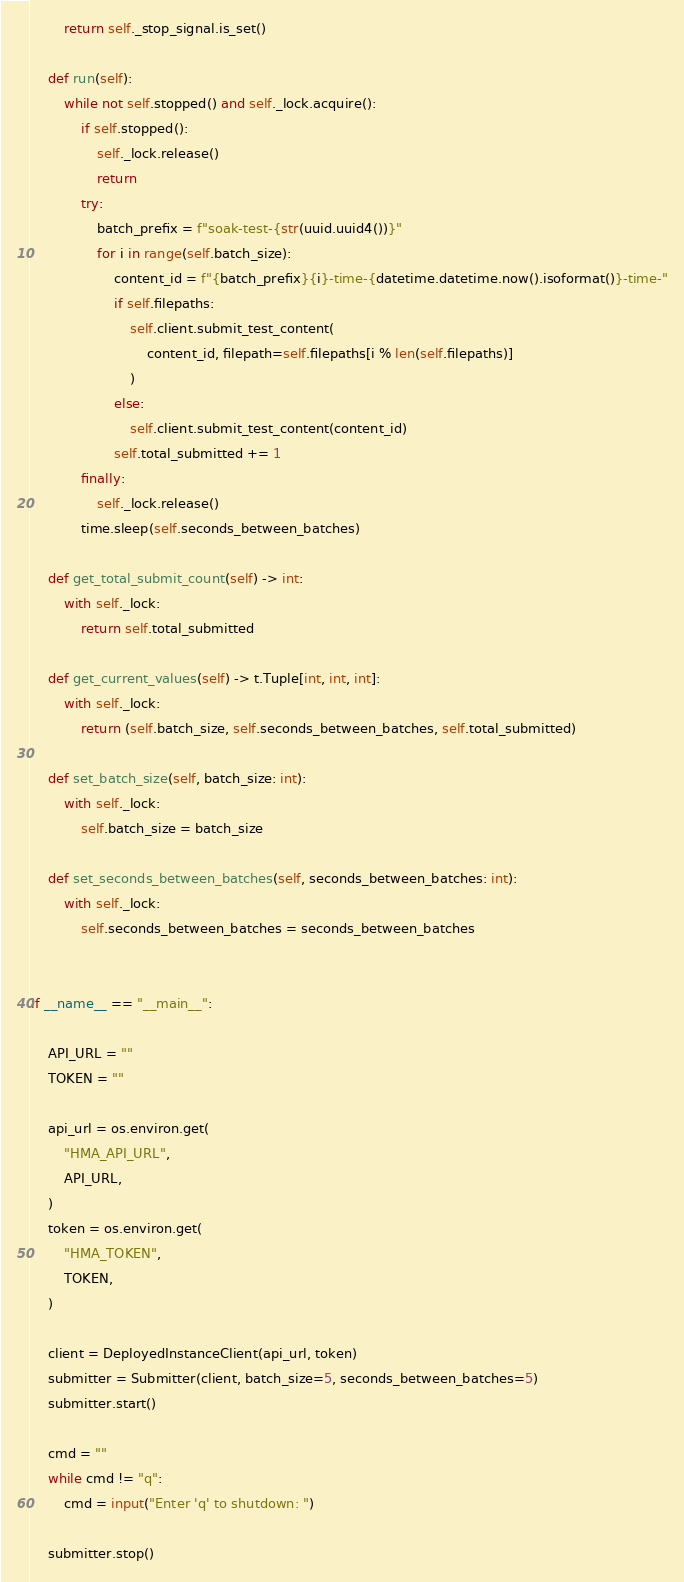<code> <loc_0><loc_0><loc_500><loc_500><_Python_>        return self._stop_signal.is_set()

    def run(self):
        while not self.stopped() and self._lock.acquire():
            if self.stopped():
                self._lock.release()
                return
            try:
                batch_prefix = f"soak-test-{str(uuid.uuid4())}"
                for i in range(self.batch_size):
                    content_id = f"{batch_prefix}{i}-time-{datetime.datetime.now().isoformat()}-time-"
                    if self.filepaths:
                        self.client.submit_test_content(
                            content_id, filepath=self.filepaths[i % len(self.filepaths)]
                        )
                    else:
                        self.client.submit_test_content(content_id)
                    self.total_submitted += 1
            finally:
                self._lock.release()
            time.sleep(self.seconds_between_batches)

    def get_total_submit_count(self) -> int:
        with self._lock:
            return self.total_submitted

    def get_current_values(self) -> t.Tuple[int, int, int]:
        with self._lock:
            return (self.batch_size, self.seconds_between_batches, self.total_submitted)

    def set_batch_size(self, batch_size: int):
        with self._lock:
            self.batch_size = batch_size

    def set_seconds_between_batches(self, seconds_between_batches: int):
        with self._lock:
            self.seconds_between_batches = seconds_between_batches


if __name__ == "__main__":

    API_URL = ""
    TOKEN = ""

    api_url = os.environ.get(
        "HMA_API_URL",
        API_URL,
    )
    token = os.environ.get(
        "HMA_TOKEN",
        TOKEN,
    )

    client = DeployedInstanceClient(api_url, token)
    submitter = Submitter(client, batch_size=5, seconds_between_batches=5)
    submitter.start()

    cmd = ""
    while cmd != "q":
        cmd = input("Enter 'q' to shutdown: ")

    submitter.stop()
</code> 